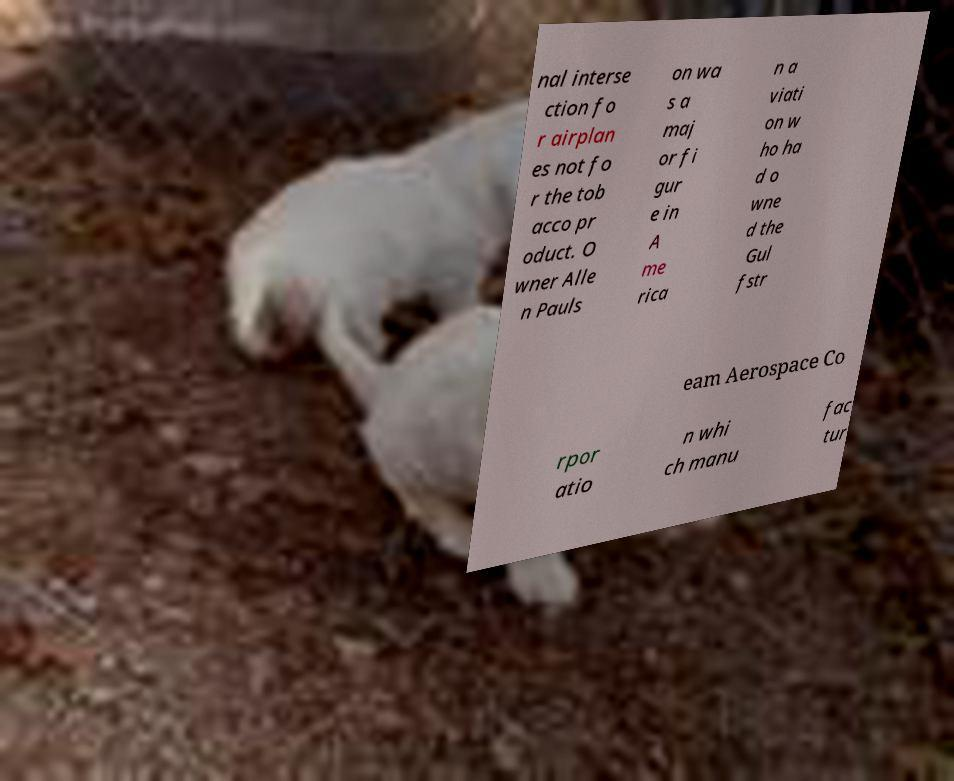For documentation purposes, I need the text within this image transcribed. Could you provide that? nal interse ction fo r airplan es not fo r the tob acco pr oduct. O wner Alle n Pauls on wa s a maj or fi gur e in A me rica n a viati on w ho ha d o wne d the Gul fstr eam Aerospace Co rpor atio n whi ch manu fac tur 